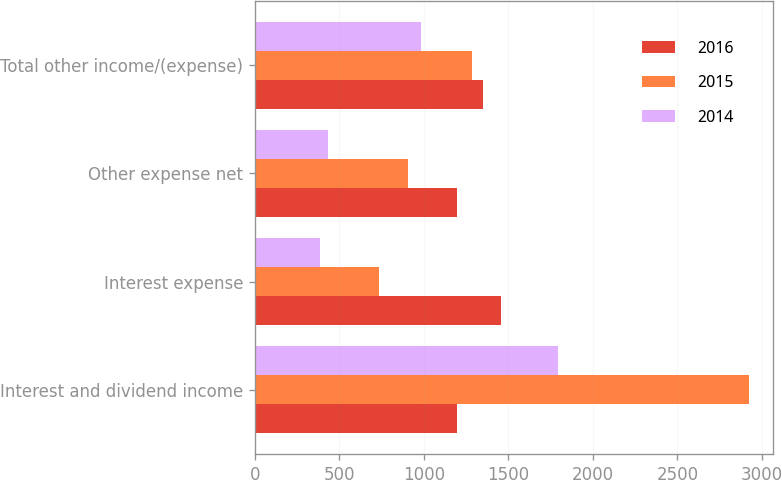Convert chart. <chart><loc_0><loc_0><loc_500><loc_500><stacked_bar_chart><ecel><fcel>Interest and dividend income<fcel>Interest expense<fcel>Other expense net<fcel>Total other income/(expense)<nl><fcel>2016<fcel>1195<fcel>1456<fcel>1195<fcel>1348<nl><fcel>2015<fcel>2921<fcel>733<fcel>903<fcel>1285<nl><fcel>2014<fcel>1795<fcel>384<fcel>431<fcel>980<nl></chart> 